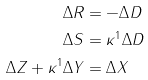<formula> <loc_0><loc_0><loc_500><loc_500>\Delta R & = - \Delta D \\ \Delta S & = \kappa ^ { 1 } \Delta D \\ \Delta Z + \kappa ^ { 1 } \Delta Y & = \Delta X</formula> 